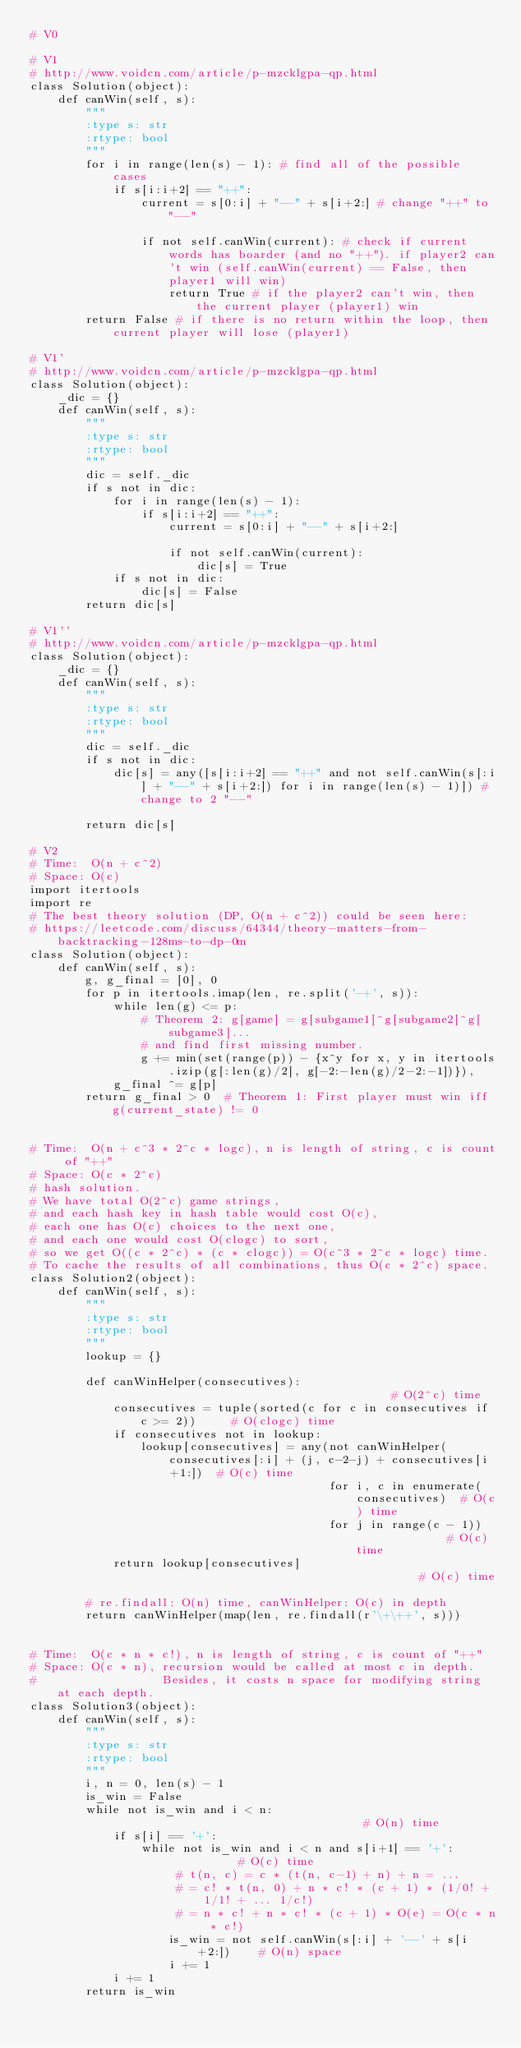Convert code to text. <code><loc_0><loc_0><loc_500><loc_500><_Python_># V0 

# V1 
# http://www.voidcn.com/article/p-mzcklgpa-qp.html
class Solution(object):
    def canWin(self, s):
        """
        :type s: str
        :rtype: bool
        """
        for i in range(len(s) - 1): # find all of the possible cases 
            if s[i:i+2] == "++": 
                current = s[0:i] + "--" + s[i+2:] # change "++" to "--"

                if not self.canWin(current): # check if current words has boarder (and no "++"). if player2 can't win (self.canWin(current) == False, then player1 will win)
                    return True # if the player2 can't win, then the current player (player1) win 
        return False # if there is no return within the loop, then current player will lose (player1)

# V1' 
# http://www.voidcn.com/article/p-mzcklgpa-qp.html
class Solution(object):
    _dic = {}
    def canWin(self, s):
        """
        :type s: str
        :rtype: bool
        """
        dic = self._dic 
        if s not in dic:
            for i in range(len(s) - 1):
                if s[i:i+2] == "++":
                    current = s[0:i] + "--" + s[i+2:]

                    if not self.canWin(current):
                        dic[s] = True
            if s not in dic:
                dic[s] = False
        return dic[s]

# V1'' 
# http://www.voidcn.com/article/p-mzcklgpa-qp.html
class Solution(object):
    _dic = {}
    def canWin(self, s):
        """
        :type s: str
        :rtype: bool
        """
        dic = self._dic
        if s not in dic:
            dic[s] = any([s[i:i+2] == "++" and not self.canWin(s[:i] + "--" + s[i+2:]) for i in range(len(s) - 1)]) # change to 2 "--"

        return dic[s]

# V2 
# Time:  O(n + c^2)
# Space: O(c)
import itertools
import re
# The best theory solution (DP, O(n + c^2)) could be seen here:
# https://leetcode.com/discuss/64344/theory-matters-from-backtracking-128ms-to-dp-0m
class Solution(object):
    def canWin(self, s):
        g, g_final = [0], 0
        for p in itertools.imap(len, re.split('-+', s)):
            while len(g) <= p:
                # Theorem 2: g[game] = g[subgame1]^g[subgame2]^g[subgame3]...
                # and find first missing number.
                g += min(set(range(p)) - {x^y for x, y in itertools.izip(g[:len(g)/2], g[-2:-len(g)/2-2:-1])}),
            g_final ^= g[p]
        return g_final > 0  # Theorem 1: First player must win iff g(current_state) != 0


# Time:  O(n + c^3 * 2^c * logc), n is length of string, c is count of "++"
# Space: O(c * 2^c)
# hash solution.
# We have total O(2^c) game strings,
# and each hash key in hash table would cost O(c),
# each one has O(c) choices to the next one,
# and each one would cost O(clogc) to sort,
# so we get O((c * 2^c) * (c * clogc)) = O(c^3 * 2^c * logc) time.
# To cache the results of all combinations, thus O(c * 2^c) space.
class Solution2(object):
    def canWin(self, s):
        """
        :type s: str
        :rtype: bool
        """
        lookup = {}

        def canWinHelper(consecutives):                                         # O(2^c) time
            consecutives = tuple(sorted(c for c in consecutives if c >= 2))     # O(clogc) time
            if consecutives not in lookup:
                lookup[consecutives] = any(not canWinHelper(consecutives[:i] + (j, c-2-j) + consecutives[i+1:])  # O(c) time
                                           for i, c in enumerate(consecutives)  # O(c) time
                                           for j in range(c - 1))              # O(c) time
            return lookup[consecutives]                                         # O(c) time

        # re.findall: O(n) time, canWinHelper: O(c) in depth
        return canWinHelper(map(len, re.findall(r'\+\++', s)))


# Time:  O(c * n * c!), n is length of string, c is count of "++"
# Space: O(c * n), recursion would be called at most c in depth.
#                  Besides, it costs n space for modifying string at each depth.
class Solution3(object):
    def canWin(self, s):
        """
        :type s: str
        :rtype: bool
        """
        i, n = 0, len(s) - 1
        is_win = False
        while not is_win and i < n:                                     # O(n) time
            if s[i] == '+':
                while not is_win and i < n and s[i+1] == '+':           # O(c) time
                     # t(n, c) = c * (t(n, c-1) + n) + n = ...
                     # = c! * t(n, 0) + n * c! * (c + 1) * (1/0! + 1/1! + ... 1/c!)
                     # = n * c! + n * c! * (c + 1) * O(e) = O(c * n * c!)
                    is_win = not self.canWin(s[:i] + '--' + s[i+2:])    # O(n) space
                    i += 1
            i += 1
        return is_win</code> 